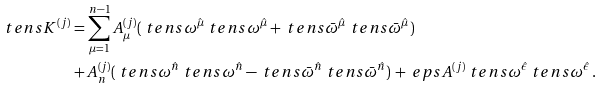<formula> <loc_0><loc_0><loc_500><loc_500>\ t e n s { K } ^ { ( j ) } = & \, \sum _ { \mu = 1 } ^ { n - 1 } A _ { \mu } ^ { ( j ) } ( \ t e n s { \omega } ^ { \hat { \mu } } \ t e n s { \omega } ^ { \hat { \mu } } + \ t e n s { \bar { \omega } } ^ { \hat { \mu } } \ t e n s { \bar { \omega } } ^ { \hat { \mu } } ) \\ + & \, A _ { n } ^ { ( j ) } ( \ t e n s { \omega } ^ { \hat { n } } \ t e n s { \omega } ^ { \hat { n } } - \ t e n s { \bar { \omega } } ^ { \hat { n } } \ t e n s { \bar { \omega } } ^ { \hat { n } } ) \, + \ e p s A ^ { ( j ) } \ t e n s { \omega } ^ { \hat { \epsilon } } \ t e n s { \omega } ^ { \hat { \epsilon } } \, .</formula> 